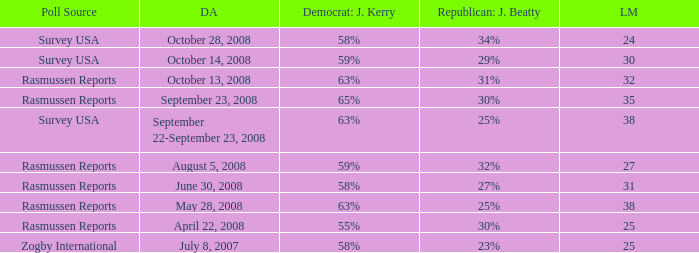What percent is the lead margin of 25 that Republican: Jeff Beatty has according to poll source Rasmussen Reports? 30%. 